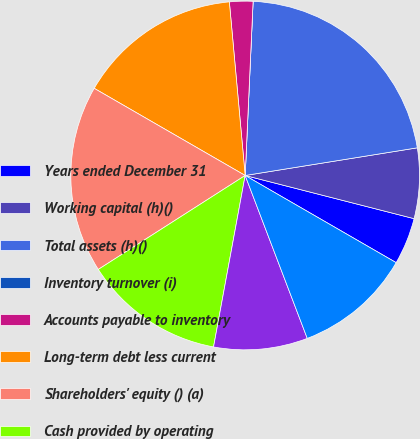Convert chart to OTSL. <chart><loc_0><loc_0><loc_500><loc_500><pie_chart><fcel>Years ended December 31<fcel>Working capital (h)()<fcel>Total assets (h)()<fcel>Inventory turnover (i)<fcel>Accounts payable to inventory<fcel>Long-term debt less current<fcel>Shareholders' equity () (a)<fcel>Cash provided by operating<fcel>Capital expenditures ()<fcel>Free cash flow (k)(l)()<nl><fcel>4.35%<fcel>6.52%<fcel>21.74%<fcel>0.0%<fcel>2.17%<fcel>15.22%<fcel>17.39%<fcel>13.04%<fcel>8.7%<fcel>10.87%<nl></chart> 